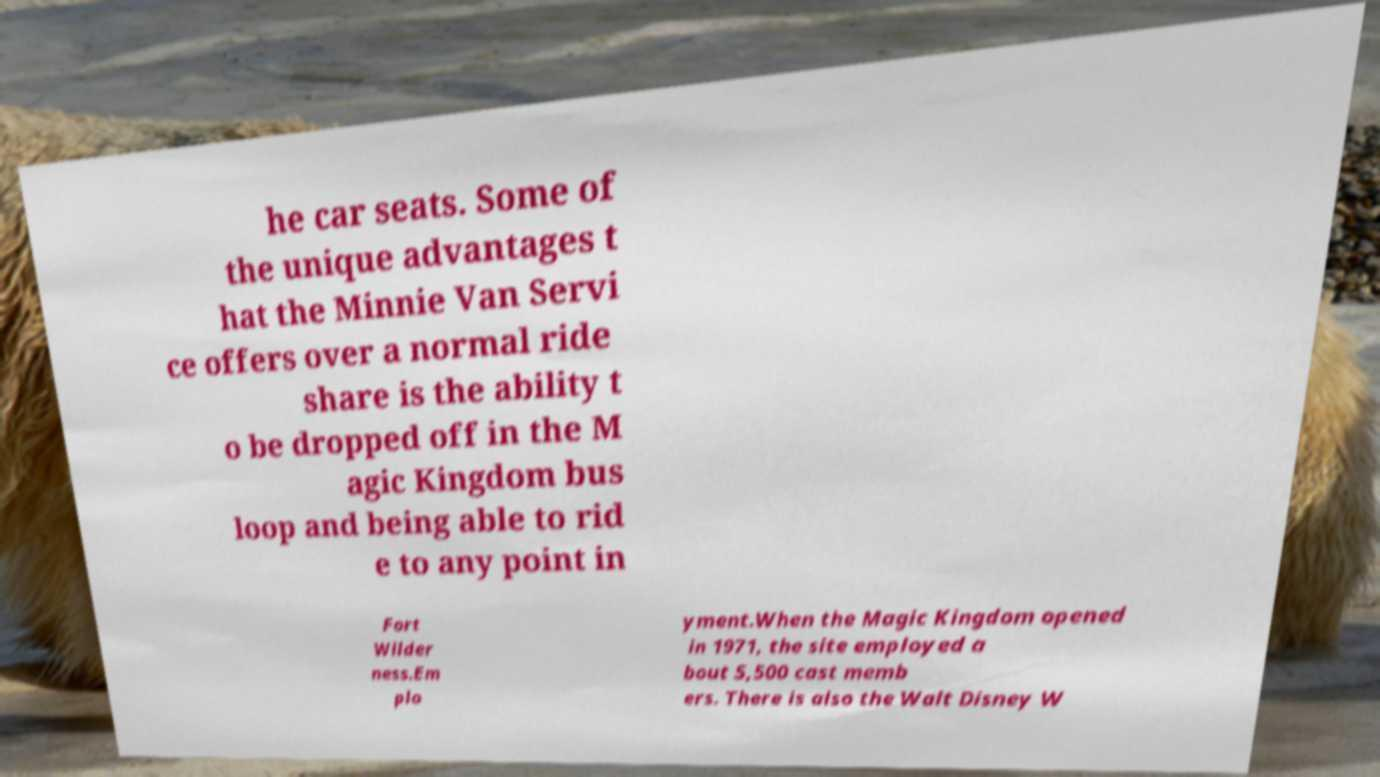Please read and relay the text visible in this image. What does it say? he car seats. Some of the unique advantages t hat the Minnie Van Servi ce offers over a normal ride share is the ability t o be dropped off in the M agic Kingdom bus loop and being able to rid e to any point in Fort Wilder ness.Em plo yment.When the Magic Kingdom opened in 1971, the site employed a bout 5,500 cast memb ers. There is also the Walt Disney W 